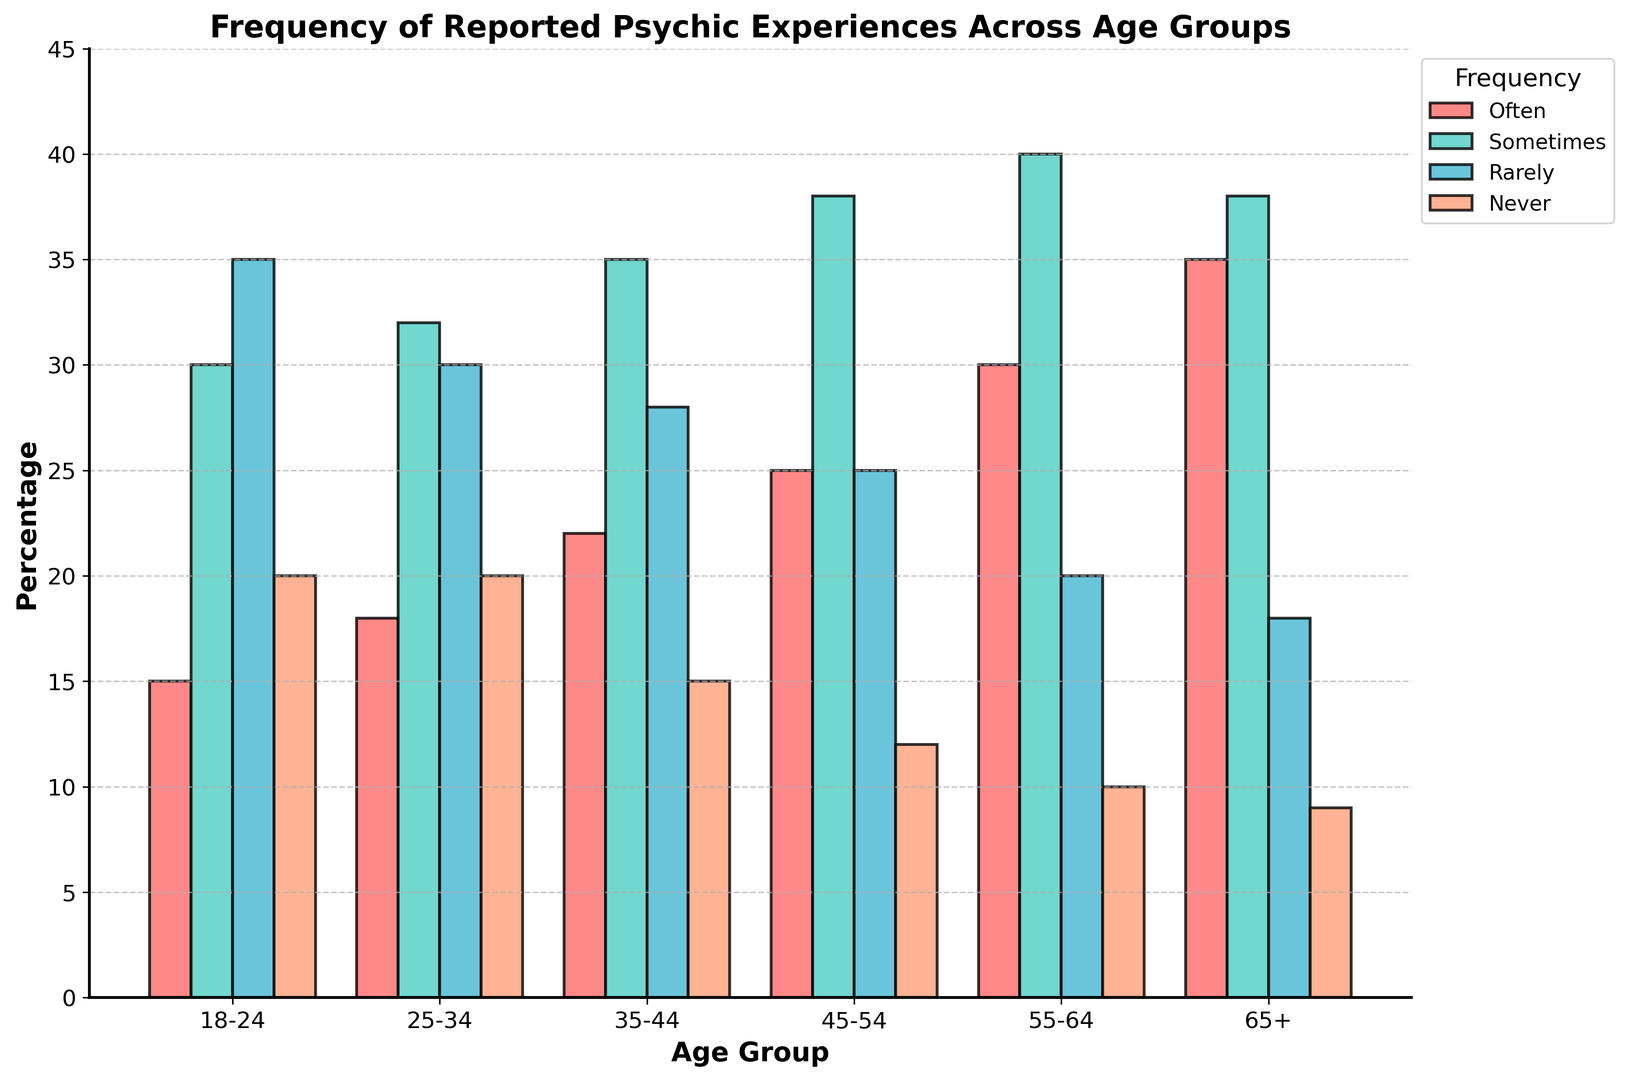Which age group reports experiencing psychic events 'Often' the most frequently? To find the age group that reports experiencing psychic events 'Often' the most frequently, look at the height of the 'Often' bars. The age group with the tallest 'Often' bar is 65+.
Answer: 65+ Which frequency category is reported similarly for the age groups 25-34 and 65+? Compare the heights of the bars for each frequency category within the age groups 25-34 and 65+. The height of the 'Sometimes' bar is almost the same for both age groups.
Answer: Sometimes In which age group is the percentage of people reporting 'Never' the lowest? Look at the heights of the 'Never' bars for each age group. The 'Never' bar is shortest in the 65+ age group.
Answer: 65+ Which age group has the highest cumulative percentage of 'Often' and 'Sometimes' reported experiences? Add the heights of the 'Often' and 'Sometimes' bars for each age group. The 65+ group has the highest cumulative percentage (35 + 38 = 73).
Answer: 65+ What is the general trend in the percentage of people reporting 'Often' experiencing psychic events as age increases? Observe the heights of the 'Often' bars across increasing age groups. The height of the 'Often' bars increases with age.
Answer: Increases Is there any age group where the percentage of 'Rarely' reported experiences is higher than 'Sometimes'? Compare the heights of 'Rarely' and 'Sometimes' bars for each age group. There is no age group where 'Rarely' is higher than 'Sometimes'.
Answer: No For the age group 45-54, how does the percentage of 'Rarely' experiences compare to 55-64? Compare the heights of the 'Rarely' bars for the 45-54 and 55-64 age groups. The 'Rarely' bar is taller for the 45-54 age group (25 vs. 20).
Answer: 45-54 is higher What is the total percentage of reported psychic experiences ('Often' + 'Sometimes' + 'Rarely' + 'Never') for the 18-24 age group? Add the heights of all the bars for the 18-24 age group: 15 + 30 + 35 + 20 = 100.
Answer: 100 Which frequency category has the smallest difference in reported experiences between the 55-64 and 65+ age groups? Calculate the difference in the heights of the bars for each frequency category: Often (30-35 = 5), Sometimes (40-38 = 2), Rarely (20-18 = 2), Never (10-9 = 1). 'Never' has the smallest difference of 1.
Answer: Never 